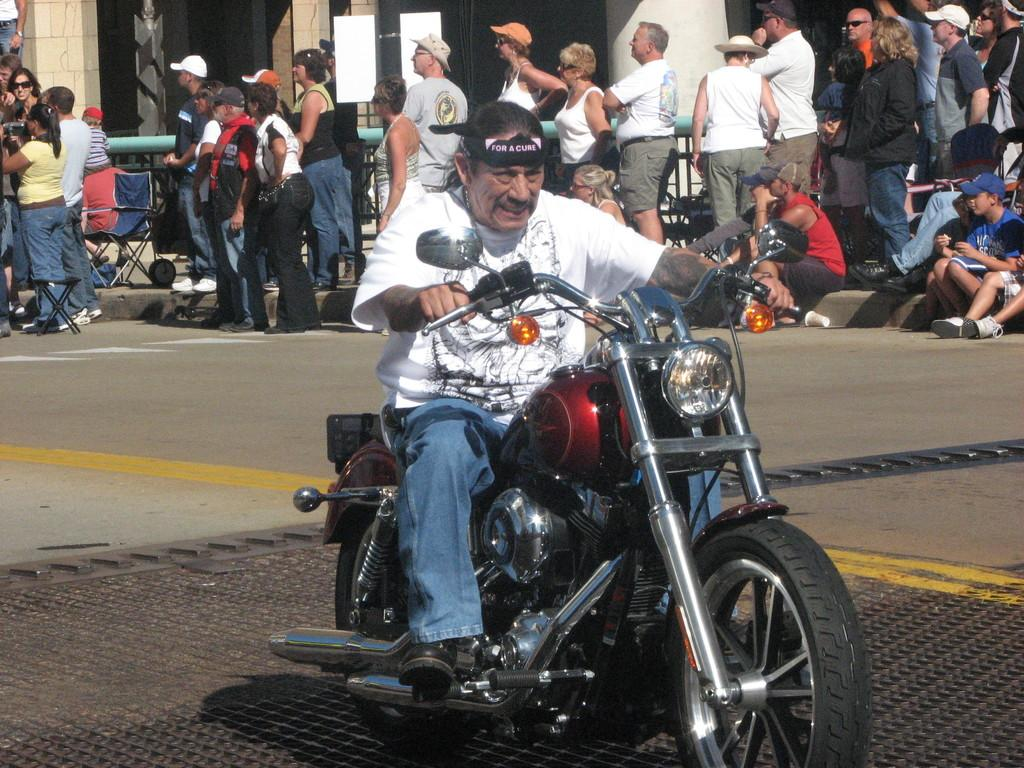What is the person in the image doing? The person is riding a bike in the image. What is the person wearing while riding the bike? The person is wearing a white shirt. Can you describe the group of people in the image? The group of people is standing behind the person riding the bike. What shape is the shop in the image? There is no shop present in the image. How many squares can be seen in the image? There are no squares visible in the image. 